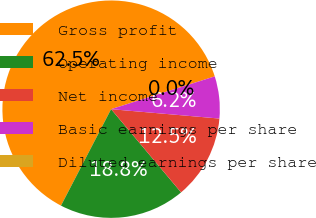Convert chart to OTSL. <chart><loc_0><loc_0><loc_500><loc_500><pie_chart><fcel>Gross profit<fcel>Operating income<fcel>Net income<fcel>Basic earnings per share<fcel>Diluted earnings per share<nl><fcel>62.5%<fcel>18.75%<fcel>12.5%<fcel>6.25%<fcel>0.0%<nl></chart> 